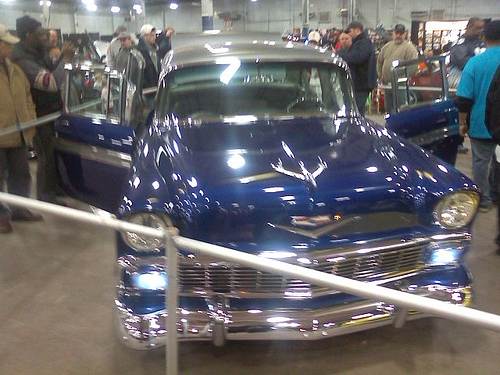<image>
Is the man to the left of the car? No. The man is not to the left of the car. From this viewpoint, they have a different horizontal relationship. 